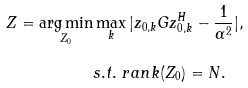Convert formula to latex. <formula><loc_0><loc_0><loc_500><loc_500>Z = \underset { Z _ { 0 } } { \arg \min } & \max _ { k } | z _ { 0 , k } G z _ { 0 , k } ^ { H } - \frac { 1 } { \alpha ^ { 2 } } | , \\ & s . t . \ r a n k ( Z _ { 0 } ) = N .</formula> 